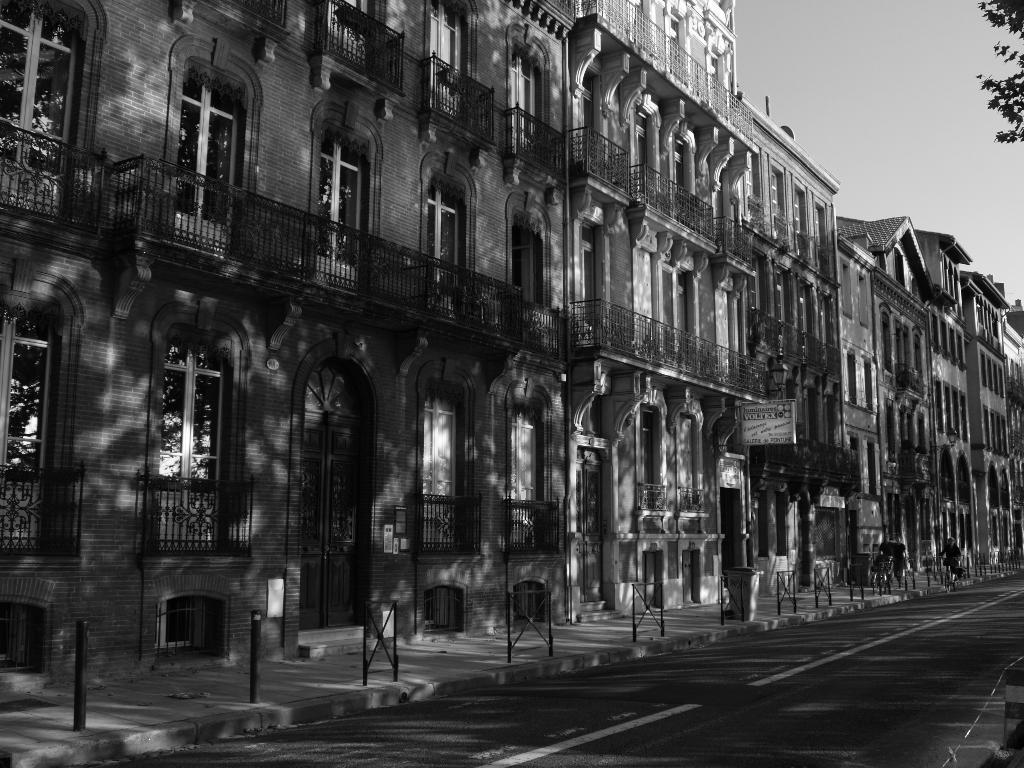Please provide a concise description of this image. In this image I can see few buildings, number of windows, few poles, leaves of a tree and I can also see lines on road. I can see this image is black and white in colour. 